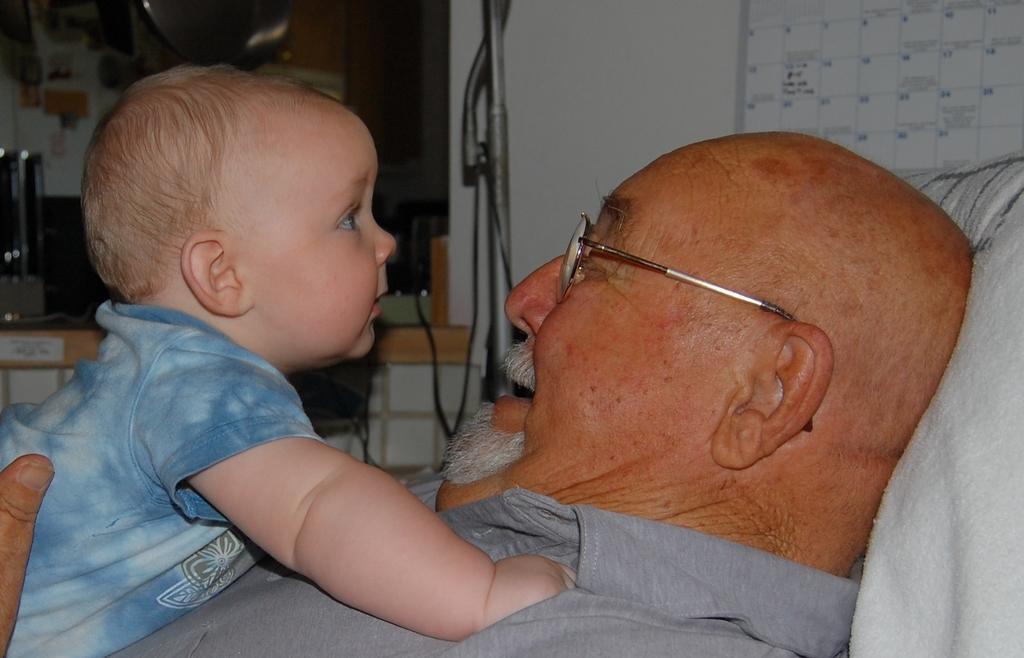Could you give a brief overview of what you see in this image? In this image I can see an old man is looking at the baby, on the left side there is a baby, this baby wore t-shirt. 